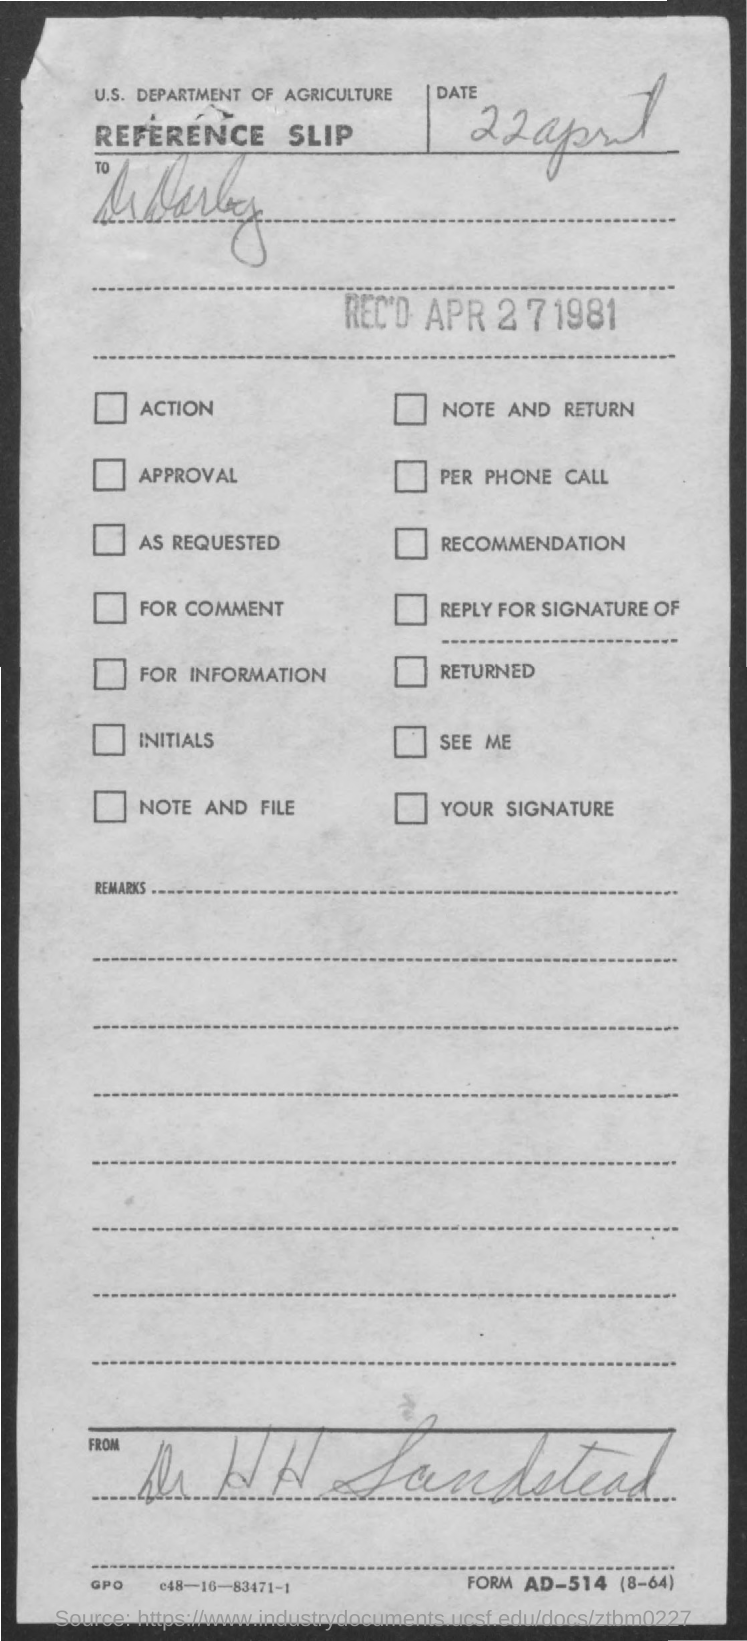What is the date mentioned in the slip ?
Offer a terse response. 22 April. What is the department mentioned in the slip ?
Give a very brief answer. U.S. Department of Agriculture. 